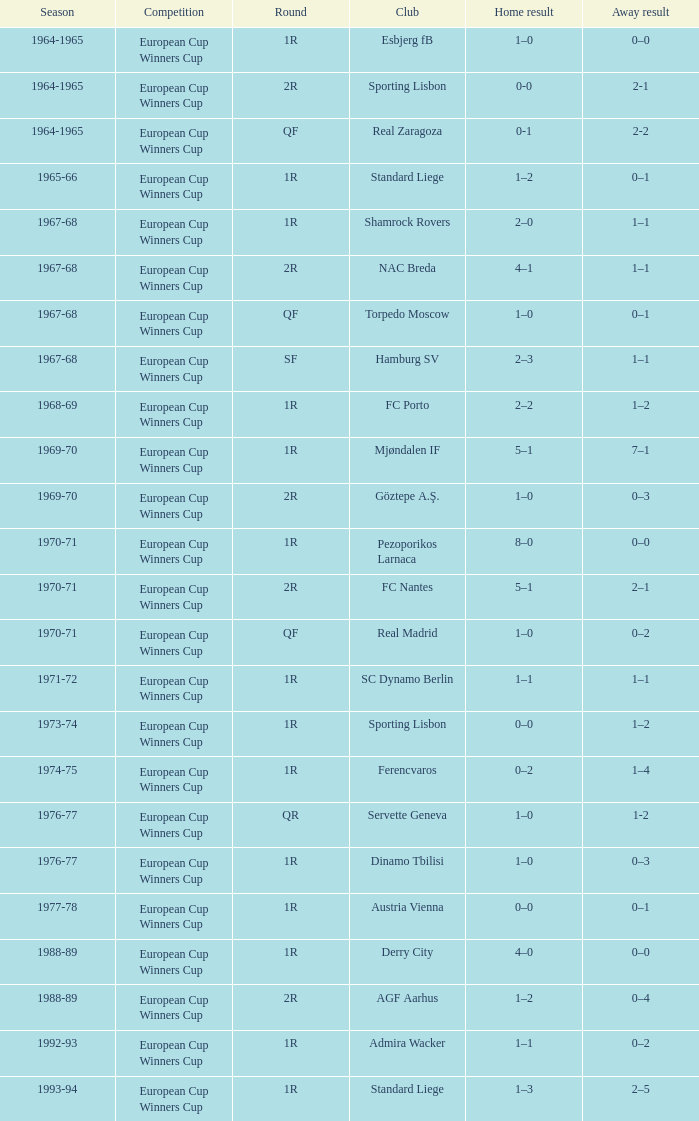Home result of 1–0, and a Away result of 0–1 involves what club? Torpedo Moscow. 